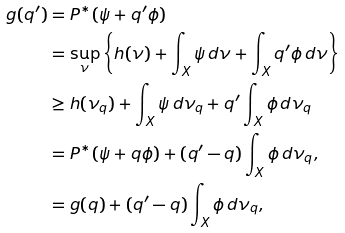Convert formula to latex. <formula><loc_0><loc_0><loc_500><loc_500>g ( q ^ { \prime } ) & = P ^ { * } ( \psi + q ^ { \prime } \phi ) \\ & = \sup _ { \nu } \left \{ h ( \nu ) + \int _ { X } \psi \, d \nu + \int _ { X } q ^ { \prime } \phi \, d \nu \right \} \\ & \geq h ( \nu _ { q } ) + \int _ { X } \psi \, d \nu _ { q } + q ^ { \prime } \int _ { X } \phi \, d \nu _ { q } \\ & = P ^ { * } ( \psi + q \phi ) + ( q ^ { \prime } - q ) \int _ { X } \phi \, d \nu _ { q } , \\ & = g ( q ) + ( q ^ { \prime } - q ) \int _ { X } \phi \, d \nu _ { q } ,</formula> 